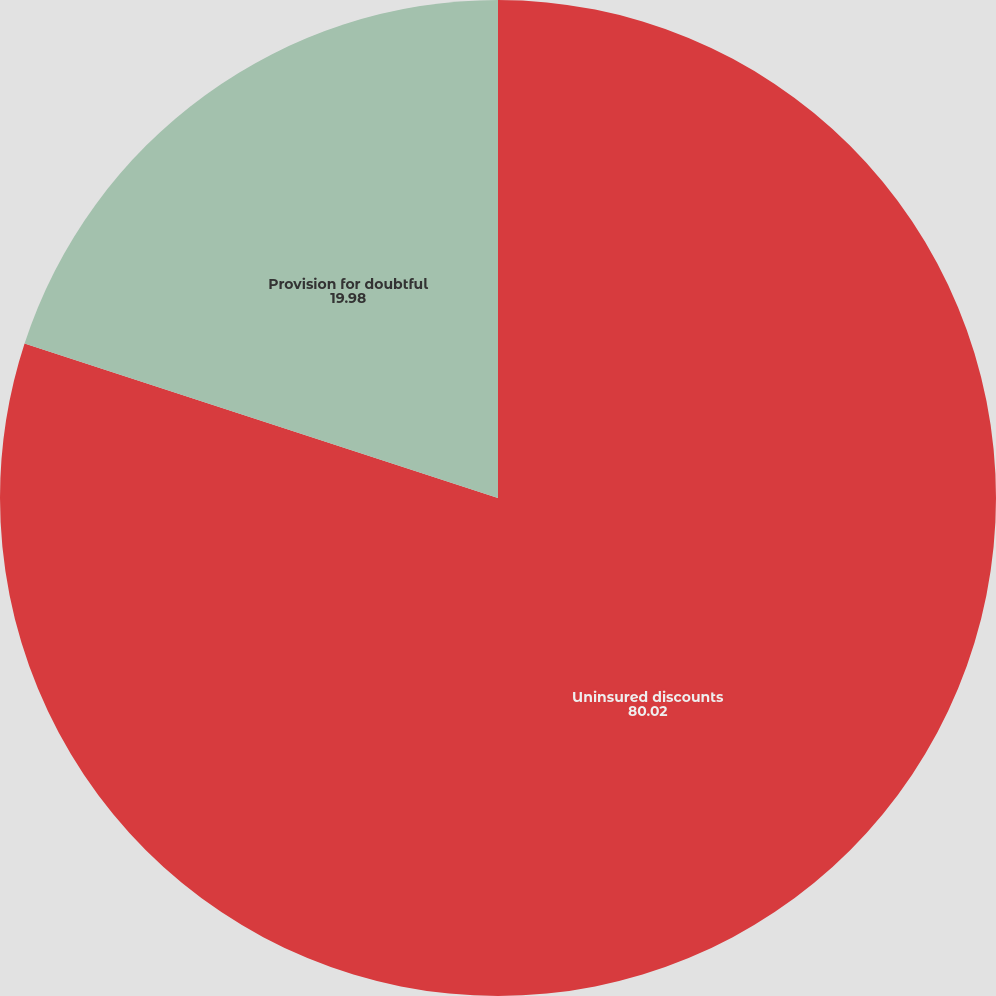<chart> <loc_0><loc_0><loc_500><loc_500><pie_chart><fcel>Uninsured discounts<fcel>Provision for doubtful<nl><fcel>80.02%<fcel>19.98%<nl></chart> 